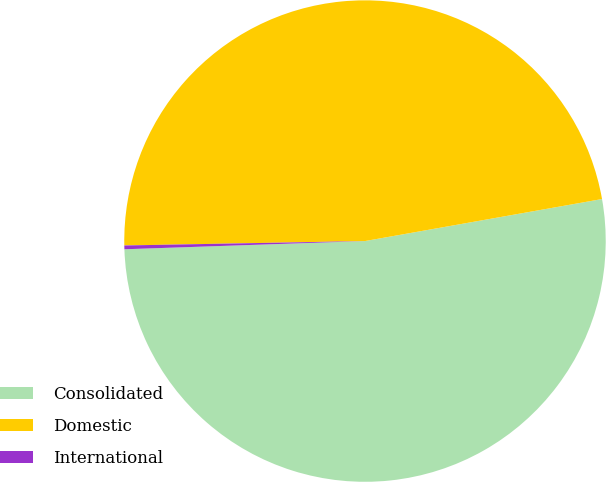Convert chart to OTSL. <chart><loc_0><loc_0><loc_500><loc_500><pie_chart><fcel>Consolidated<fcel>Domestic<fcel>International<nl><fcel>52.25%<fcel>47.5%<fcel>0.25%<nl></chart> 